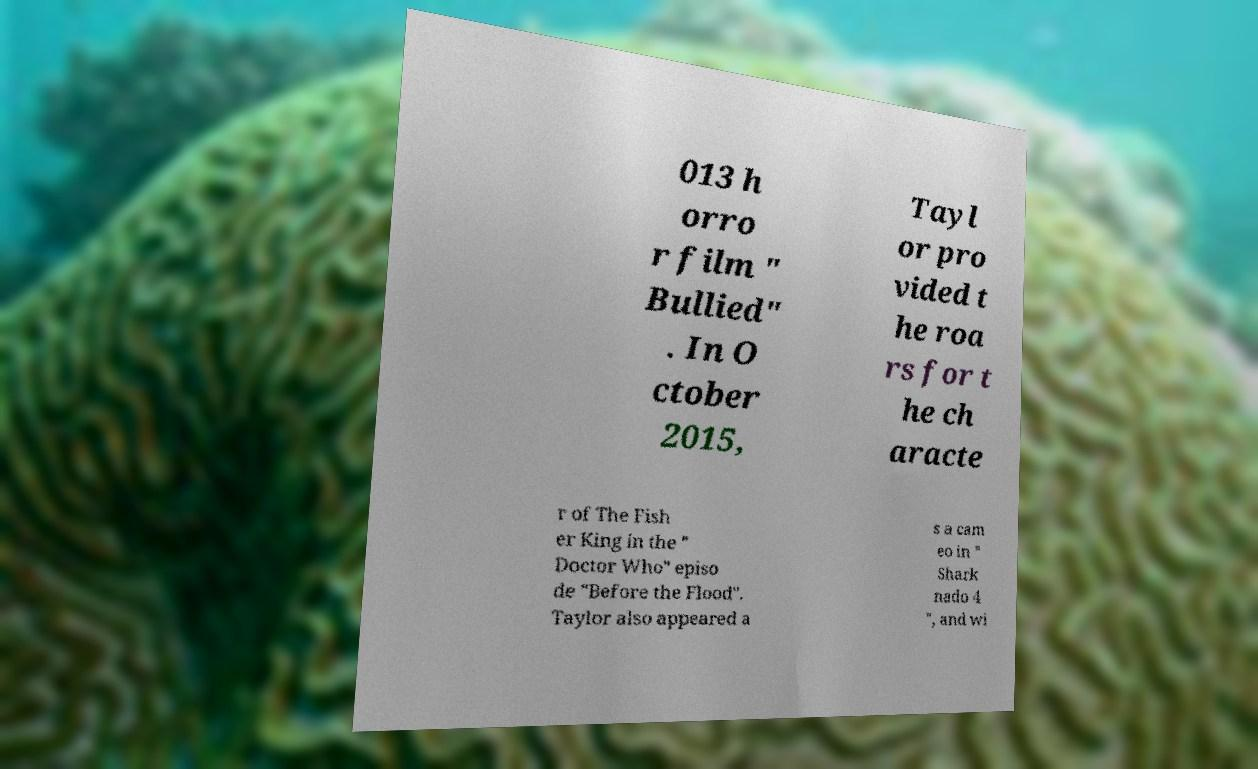Can you accurately transcribe the text from the provided image for me? 013 h orro r film " Bullied" . In O ctober 2015, Tayl or pro vided t he roa rs for t he ch aracte r of The Fish er King in the " Doctor Who" episo de "Before the Flood". Taylor also appeared a s a cam eo in " Shark nado 4 ", and wi 